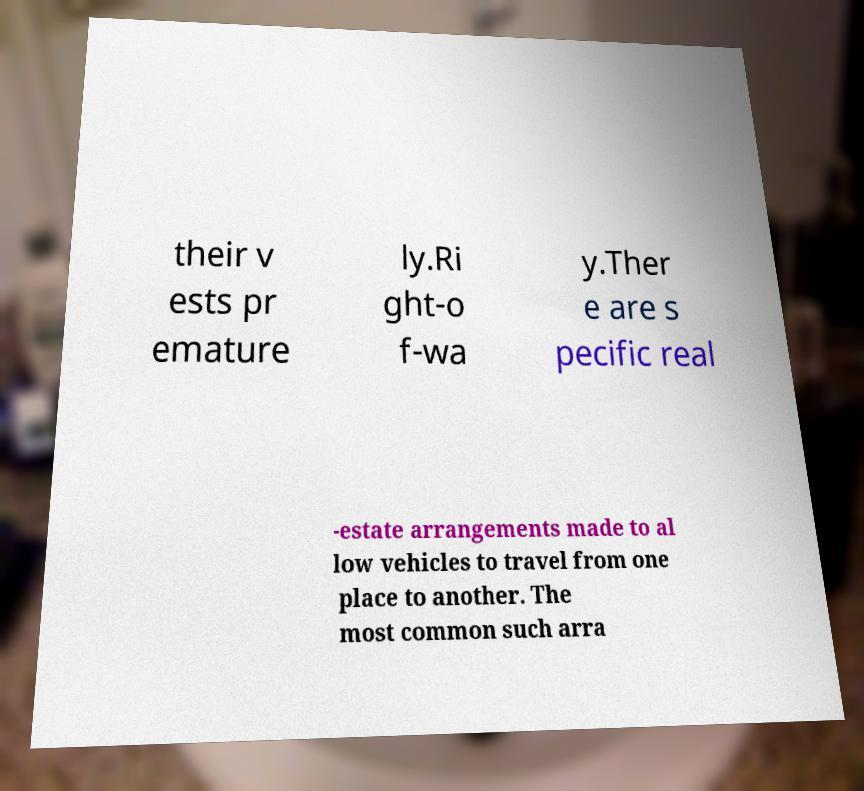For documentation purposes, I need the text within this image transcribed. Could you provide that? their v ests pr emature ly.Ri ght-o f-wa y.Ther e are s pecific real -estate arrangements made to al low vehicles to travel from one place to another. The most common such arra 